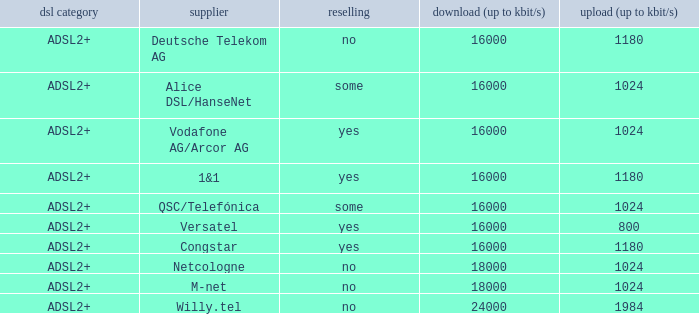Who are all of the telecom providers for which the upload rate is 1024 kbits and the resale category is yes? Vodafone AG/Arcor AG. 